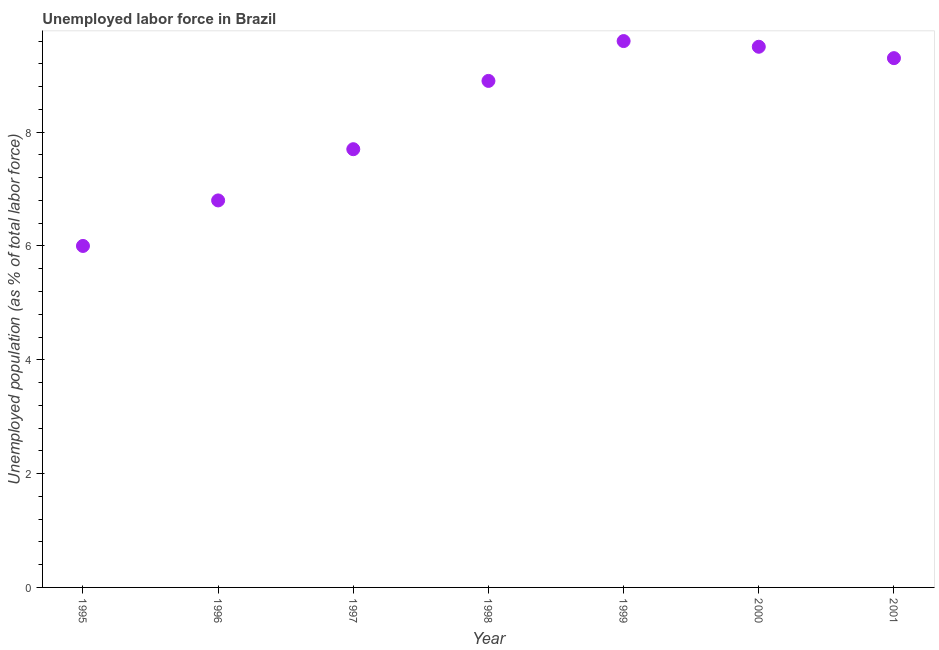What is the total unemployed population in 1996?
Give a very brief answer. 6.8. Across all years, what is the maximum total unemployed population?
Provide a succinct answer. 9.6. In which year was the total unemployed population maximum?
Give a very brief answer. 1999. What is the sum of the total unemployed population?
Make the answer very short. 57.8. What is the difference between the total unemployed population in 1995 and 2000?
Offer a terse response. -3.5. What is the average total unemployed population per year?
Your answer should be compact. 8.26. What is the median total unemployed population?
Keep it short and to the point. 8.9. In how many years, is the total unemployed population greater than 8 %?
Make the answer very short. 4. What is the ratio of the total unemployed population in 1996 to that in 1997?
Offer a very short reply. 0.88. What is the difference between the highest and the second highest total unemployed population?
Keep it short and to the point. 0.1. Is the sum of the total unemployed population in 1997 and 1999 greater than the maximum total unemployed population across all years?
Your answer should be very brief. Yes. What is the difference between the highest and the lowest total unemployed population?
Give a very brief answer. 3.6. Does the total unemployed population monotonically increase over the years?
Offer a terse response. No. How many years are there in the graph?
Offer a very short reply. 7. What is the title of the graph?
Provide a succinct answer. Unemployed labor force in Brazil. What is the label or title of the Y-axis?
Keep it short and to the point. Unemployed population (as % of total labor force). What is the Unemployed population (as % of total labor force) in 1995?
Ensure brevity in your answer.  6. What is the Unemployed population (as % of total labor force) in 1996?
Your answer should be compact. 6.8. What is the Unemployed population (as % of total labor force) in 1997?
Your answer should be very brief. 7.7. What is the Unemployed population (as % of total labor force) in 1998?
Ensure brevity in your answer.  8.9. What is the Unemployed population (as % of total labor force) in 1999?
Offer a terse response. 9.6. What is the Unemployed population (as % of total labor force) in 2000?
Provide a short and direct response. 9.5. What is the Unemployed population (as % of total labor force) in 2001?
Give a very brief answer. 9.3. What is the difference between the Unemployed population (as % of total labor force) in 1995 and 2000?
Provide a short and direct response. -3.5. What is the difference between the Unemployed population (as % of total labor force) in 1995 and 2001?
Offer a very short reply. -3.3. What is the difference between the Unemployed population (as % of total labor force) in 1996 and 1998?
Give a very brief answer. -2.1. What is the difference between the Unemployed population (as % of total labor force) in 1996 and 2001?
Make the answer very short. -2.5. What is the difference between the Unemployed population (as % of total labor force) in 1998 and 2000?
Ensure brevity in your answer.  -0.6. What is the difference between the Unemployed population (as % of total labor force) in 1998 and 2001?
Provide a short and direct response. -0.4. What is the ratio of the Unemployed population (as % of total labor force) in 1995 to that in 1996?
Make the answer very short. 0.88. What is the ratio of the Unemployed population (as % of total labor force) in 1995 to that in 1997?
Ensure brevity in your answer.  0.78. What is the ratio of the Unemployed population (as % of total labor force) in 1995 to that in 1998?
Provide a short and direct response. 0.67. What is the ratio of the Unemployed population (as % of total labor force) in 1995 to that in 2000?
Keep it short and to the point. 0.63. What is the ratio of the Unemployed population (as % of total labor force) in 1995 to that in 2001?
Your response must be concise. 0.65. What is the ratio of the Unemployed population (as % of total labor force) in 1996 to that in 1997?
Provide a succinct answer. 0.88. What is the ratio of the Unemployed population (as % of total labor force) in 1996 to that in 1998?
Ensure brevity in your answer.  0.76. What is the ratio of the Unemployed population (as % of total labor force) in 1996 to that in 1999?
Give a very brief answer. 0.71. What is the ratio of the Unemployed population (as % of total labor force) in 1996 to that in 2000?
Make the answer very short. 0.72. What is the ratio of the Unemployed population (as % of total labor force) in 1996 to that in 2001?
Give a very brief answer. 0.73. What is the ratio of the Unemployed population (as % of total labor force) in 1997 to that in 1998?
Your response must be concise. 0.86. What is the ratio of the Unemployed population (as % of total labor force) in 1997 to that in 1999?
Ensure brevity in your answer.  0.8. What is the ratio of the Unemployed population (as % of total labor force) in 1997 to that in 2000?
Offer a terse response. 0.81. What is the ratio of the Unemployed population (as % of total labor force) in 1997 to that in 2001?
Ensure brevity in your answer.  0.83. What is the ratio of the Unemployed population (as % of total labor force) in 1998 to that in 1999?
Your response must be concise. 0.93. What is the ratio of the Unemployed population (as % of total labor force) in 1998 to that in 2000?
Your answer should be very brief. 0.94. What is the ratio of the Unemployed population (as % of total labor force) in 1999 to that in 2001?
Give a very brief answer. 1.03. What is the ratio of the Unemployed population (as % of total labor force) in 2000 to that in 2001?
Your response must be concise. 1.02. 